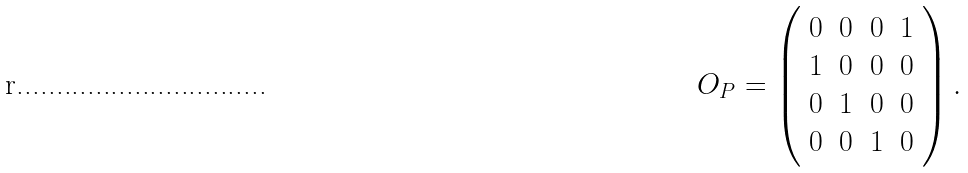<formula> <loc_0><loc_0><loc_500><loc_500>O _ { P } = \left ( \begin{array} { c c c c } 0 & 0 & 0 & 1 \\ 1 & 0 & 0 & 0 \\ 0 & 1 & 0 & 0 \\ 0 & 0 & 1 & 0 \end{array} \right ) .</formula> 